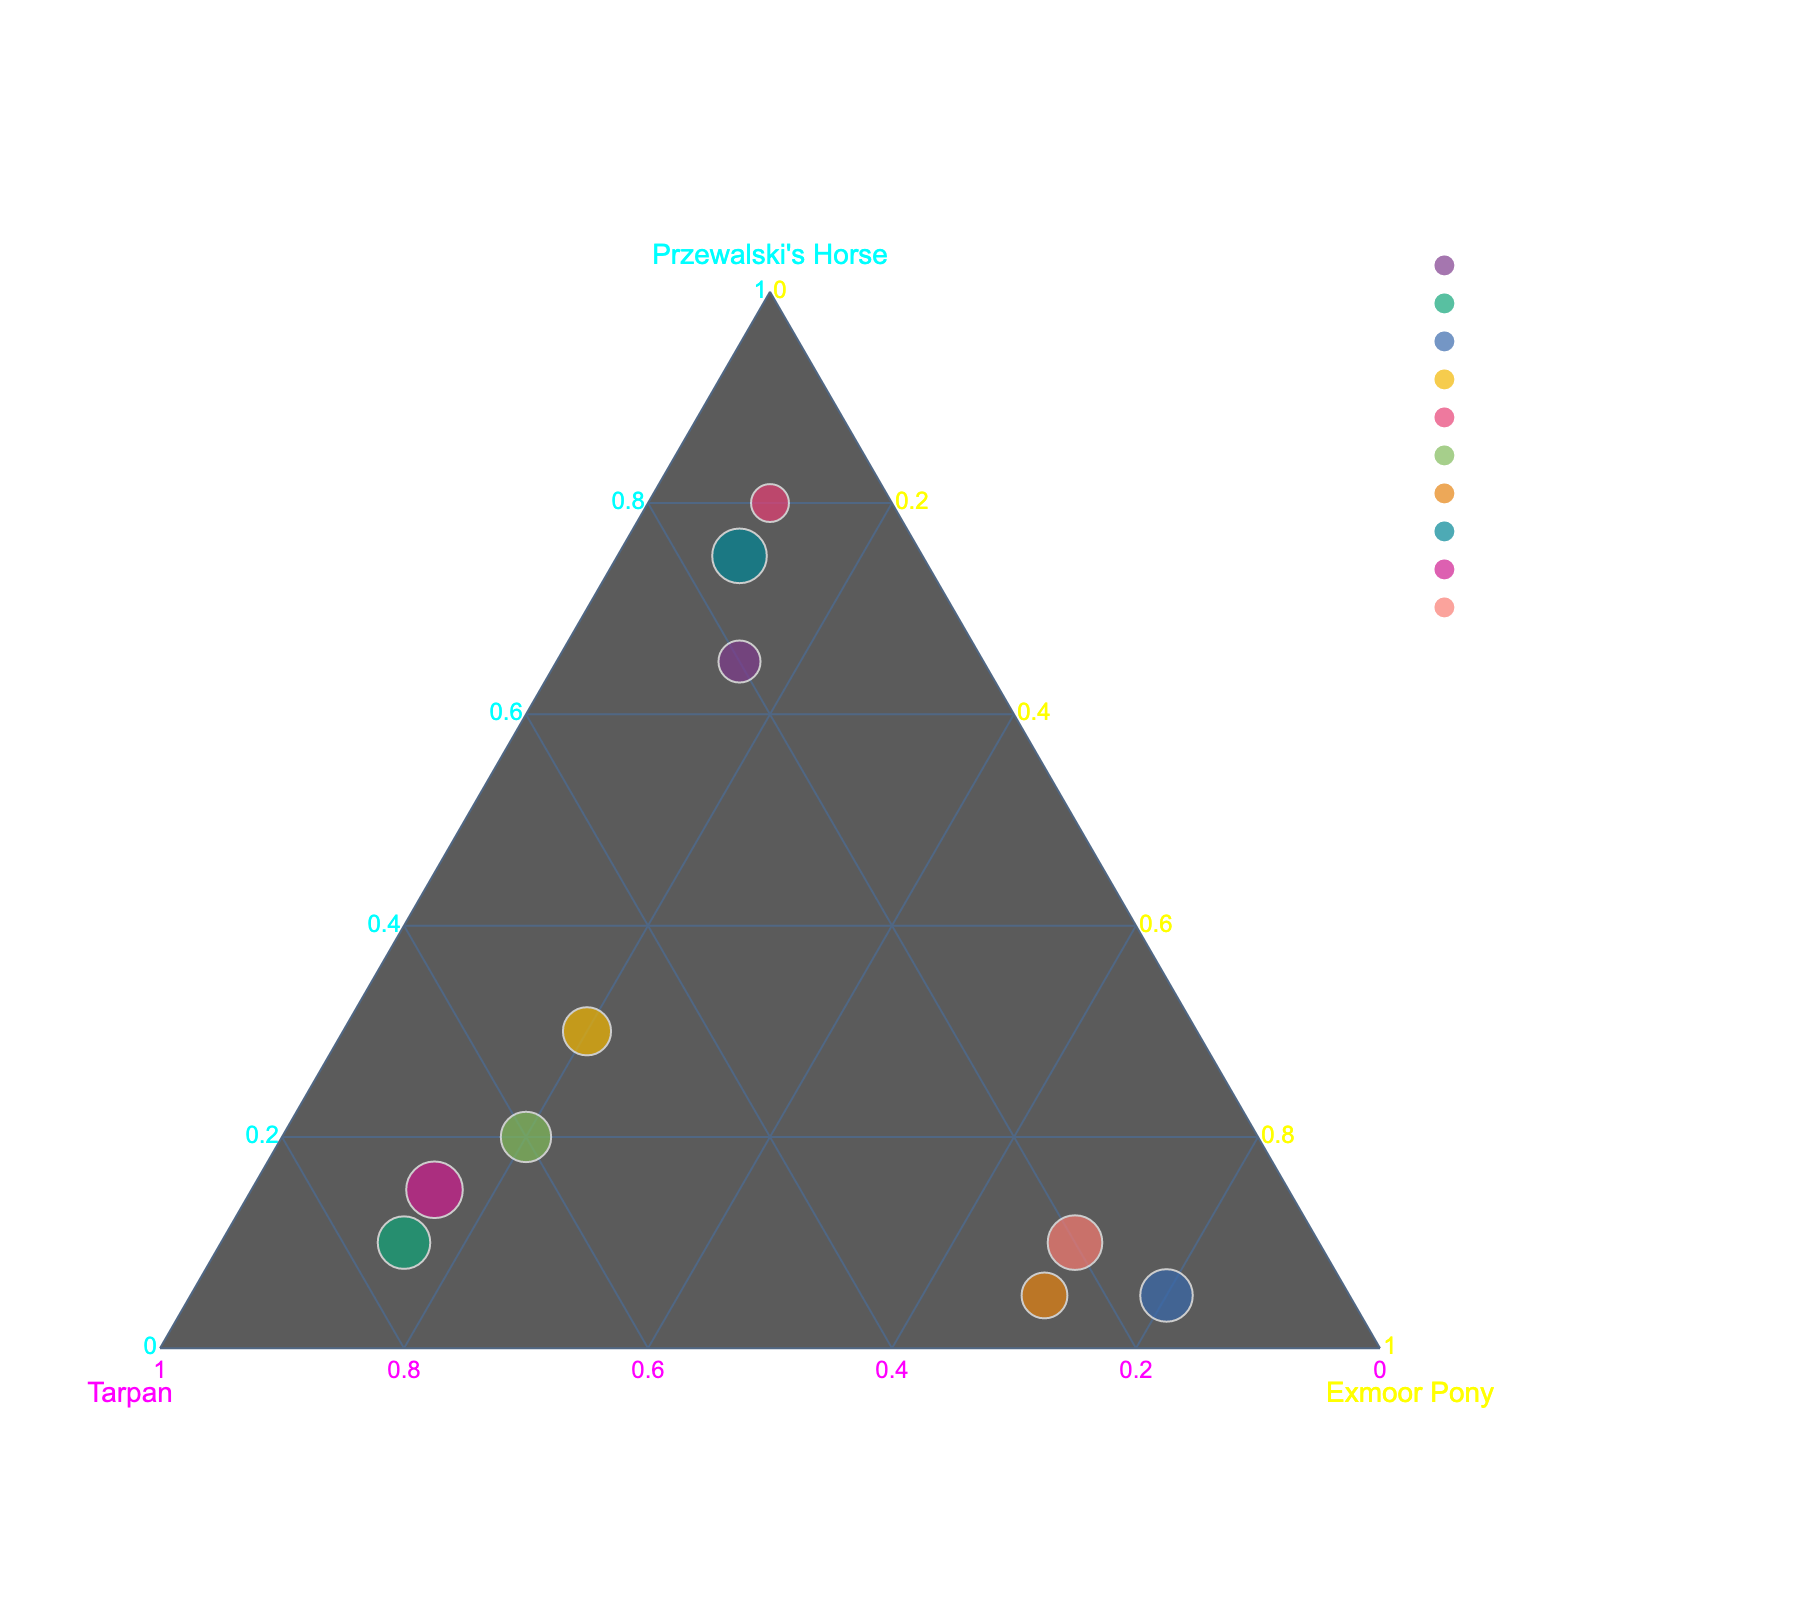How many habitats are represented in the plot? Look at the legend in the plot, which shows unique colors for each habitat. Count the number of distinct habitats displayed.
Answer: 10 What is the title of the plot? Observe the title at the top of the plot. It provides a description of what the plot represents.
Answer: "Genetic Composition of Endangered Horse Subspecies Across Habitats" Which habitat shows the highest proportion of Exmoor Pony? Look for the point located closest to the vertex labeled "Exmoor Pony" because points near this vertex indicate a higher proportion of Exmoor Pony. The corresponding habitat name can be found using the hover feature.
Answer: "Exmoor National Park" Compare the proportions of Tarpan and Exmoor Pony in the Chernobyl Exclusion Zone habitat. Which is higher? Locate the Chernobyl Exclusion Zone point. Check its position relative to the vertices labeled "Tarpan" and "Exmoor Pony." The proportions can be verified using the hover feature.
Answer: Tarpan Which habitat has the most similar genetic composition to the Great Hungarian Plain in terms of Tarpan proportions? Compare the Tarpan proportions of each habitat to find the one that is closest to the Great Hungarian Plain (0.60). This can be verified visually and using the hover feature if necessary.
Answer: Polish Primeval Forest Which horse subspecies is the least dominant in the Khustain Nuruu habitat? Look at the Khustain Nuruu point and check its proximity to the three vertices. The least dominant subspecies will be the farthest vertex. Confirm using the hover feature.
Answer: Exmoor Pony Calculate the average proportion of Przewalski's Horse across all habitats. Sum the Przewalski's Horse proportions for all habitats and then divide by the number of habitats (0.65 + 0.10 + 0.05 + 0.30 + 0.80 + 0.20 + 0.05 + 0.75 + 0.15 + 0.10) / 10 = 3.15 / 10.
Answer: 0.315 Which habitat has an equal proportion of Tarpan and Exmoor Pony? Find the point where the proportions of Tarpan and Exmoor Pony are equal. Verify by using the hover feature.
Answer: Great Hungarian Plain What is the total proportion of Przewalski's Horse and Exmoor Pony in the Dartmoor habitat? Identify the Dartmoor point and check its values for Przewalski's Horse and Exmoor Pony. Add these two values (0.05 + 0.70). Confirm using the hover feature if necessary.
Answer: 0.75 Among the listed habitats, which one has the lowest proportion of Przewalski's Horse? Identify the habitat with the point closest to the vertices labeled "Tarpan" and "Exmoor Pony," indicating a lower proportion of Przewalski's Horse. Confirm using the hover feature.
Answer: Exmoor National Park 